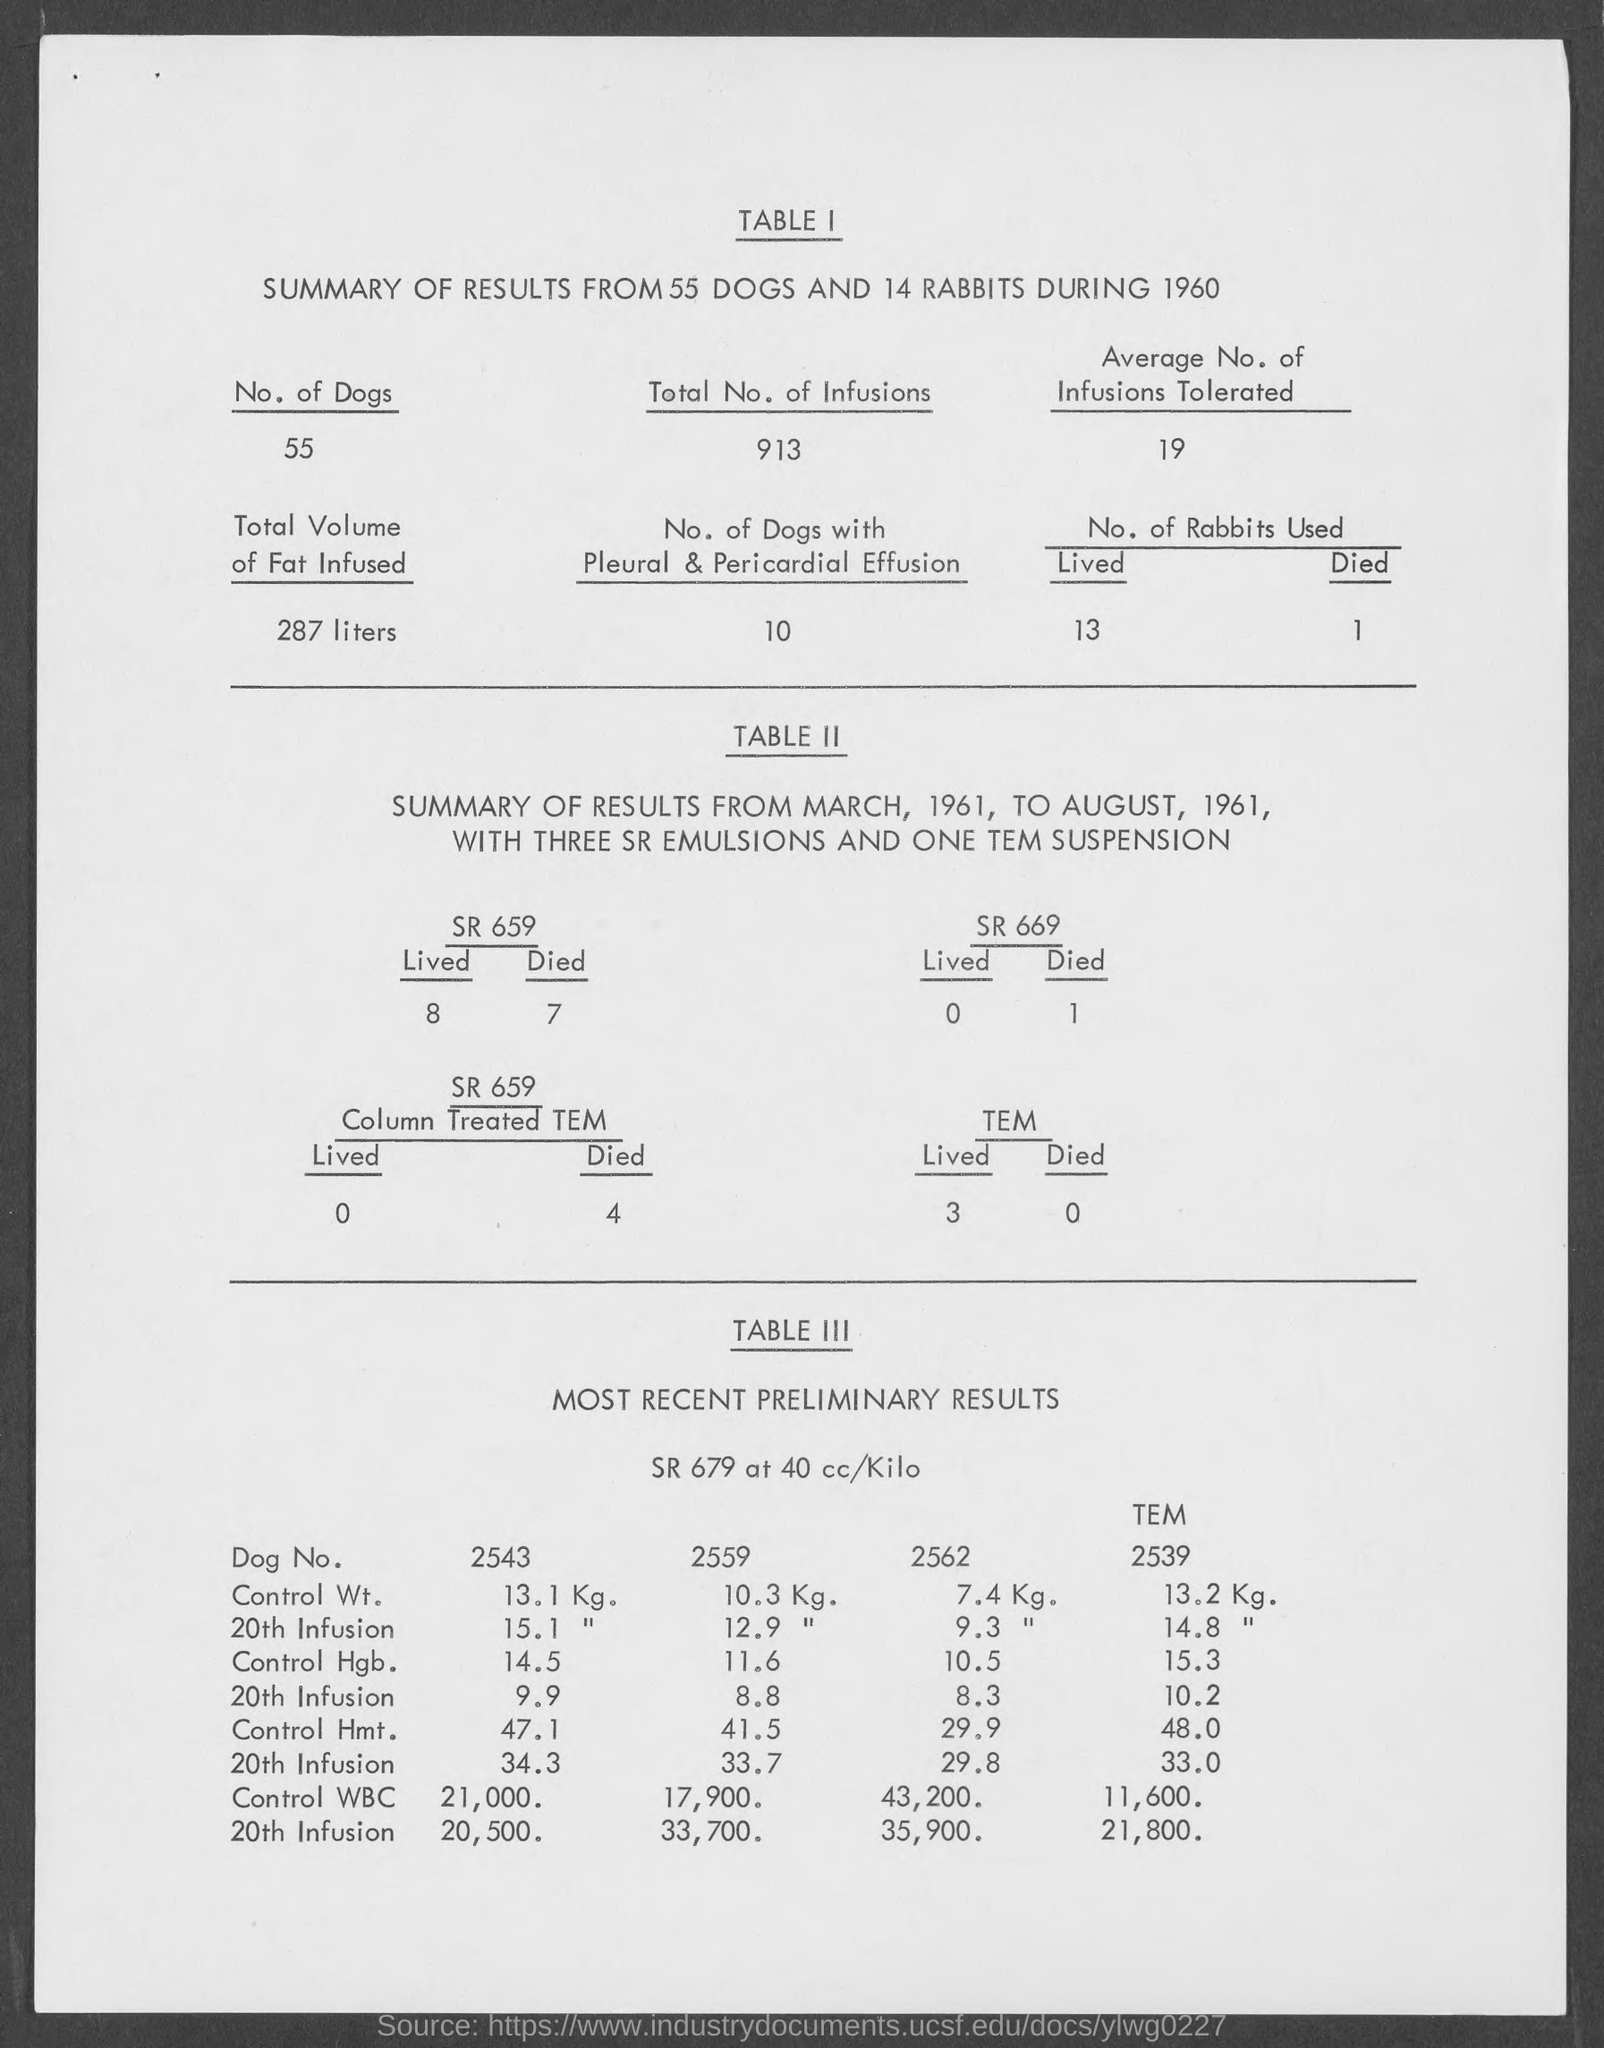Give some essential details in this illustration. According to TABLE I, the number of dogs with pleural and pericardial effusion is 10. The total number of infusions listed in TABLE 1 is 913. The number of dogs mentioned in TABLE 1 is 55. The title of TABLE I is "SUMMARY OF RESULTS FROM 55 DOGS AND 14 RABBITS DURING 1960. According to TABLE 1, the average number of infusions tolerated is 19. 